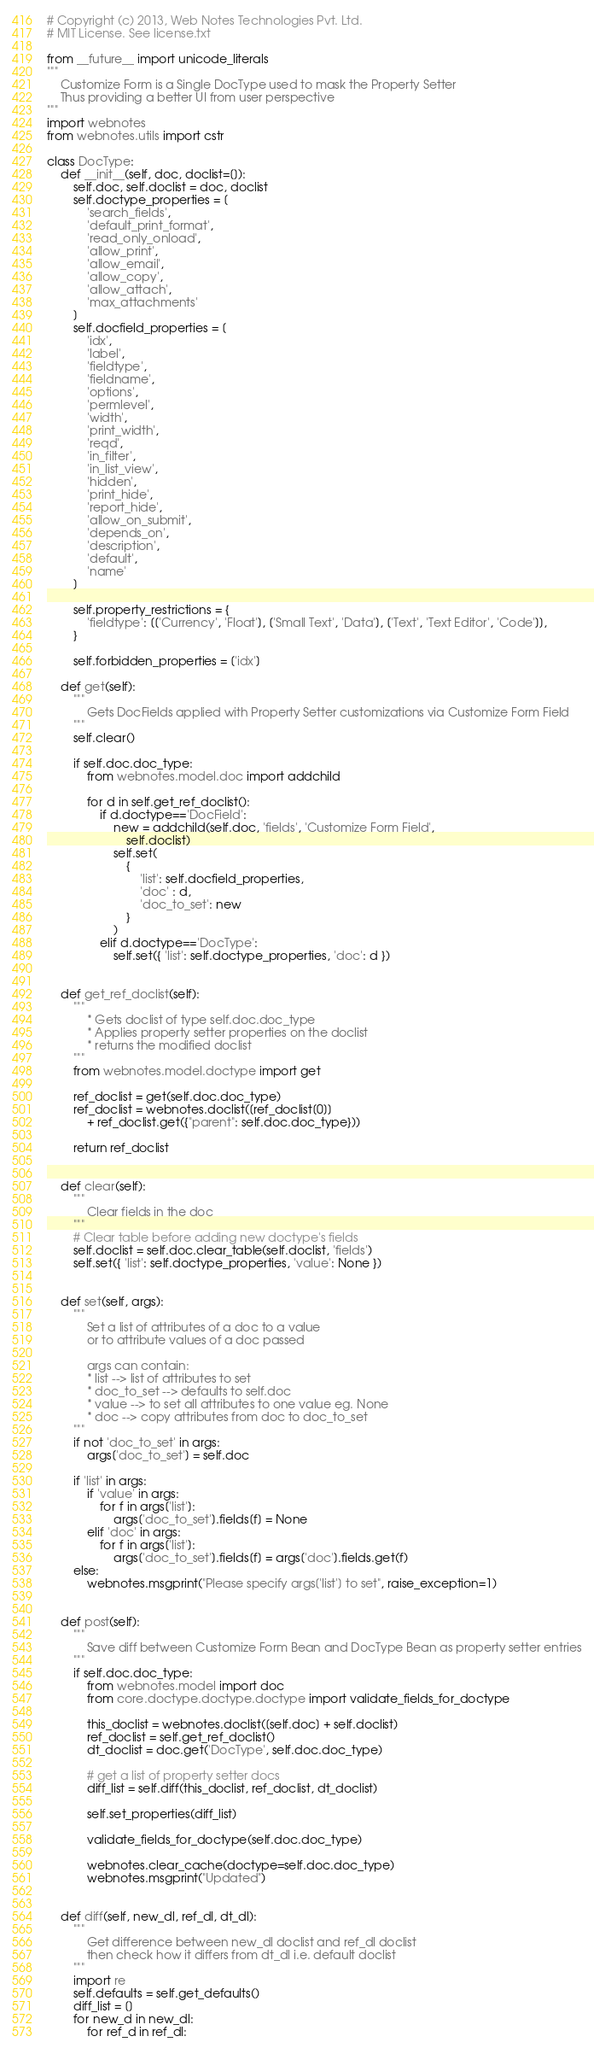<code> <loc_0><loc_0><loc_500><loc_500><_Python_># Copyright (c) 2013, Web Notes Technologies Pvt. Ltd.
# MIT License. See license.txt 

from __future__ import unicode_literals
"""
	Customize Form is a Single DocType used to mask the Property Setter
	Thus providing a better UI from user perspective
"""
import webnotes
from webnotes.utils import cstr

class DocType:
	def __init__(self, doc, doclist=[]):
		self.doc, self.doclist = doc, doclist
		self.doctype_properties = [
			'search_fields',
			'default_print_format',
			'read_only_onload',
			'allow_print',
			'allow_email',
			'allow_copy',
			'allow_attach',
			'max_attachments' 
		]
		self.docfield_properties = [
			'idx',
			'label',
			'fieldtype',
			'fieldname',
			'options',
			'permlevel',
			'width',
			'print_width',
			'reqd',
			'in_filter',
			'in_list_view',
			'hidden',
			'print_hide',
			'report_hide',
			'allow_on_submit',
			'depends_on',
			'description',
			'default',
			'name'
		]

		self.property_restrictions = {
			'fieldtype': [['Currency', 'Float'], ['Small Text', 'Data'], ['Text', 'Text Editor', 'Code']],
		}

		self.forbidden_properties = ['idx']

	def get(self):
		"""
			Gets DocFields applied with Property Setter customizations via Customize Form Field
		"""
		self.clear()

		if self.doc.doc_type:
			from webnotes.model.doc import addchild

			for d in self.get_ref_doclist():
				if d.doctype=='DocField':
					new = addchild(self.doc, 'fields', 'Customize Form Field', 
						self.doclist)
					self.set(
						{
							'list': self.docfield_properties,
							'doc' : d,
							'doc_to_set': new
						}
					)
				elif d.doctype=='DocType':
					self.set({ 'list': self.doctype_properties, 'doc': d })


	def get_ref_doclist(self):
		"""
			* Gets doclist of type self.doc.doc_type
			* Applies property setter properties on the doclist
			* returns the modified doclist
		"""
		from webnotes.model.doctype import get
		
		ref_doclist = get(self.doc.doc_type)
		ref_doclist = webnotes.doclist([ref_doclist[0]] 
			+ ref_doclist.get({"parent": self.doc.doc_type}))

		return ref_doclist


	def clear(self):
		"""
			Clear fields in the doc
		"""
		# Clear table before adding new doctype's fields
		self.doclist = self.doc.clear_table(self.doclist, 'fields')
		self.set({ 'list': self.doctype_properties, 'value': None })
	
		
	def set(self, args):
		"""
			Set a list of attributes of a doc to a value
			or to attribute values of a doc passed
			
			args can contain:
			* list --> list of attributes to set
			* doc_to_set --> defaults to self.doc
			* value --> to set all attributes to one value eg. None
			* doc --> copy attributes from doc to doc_to_set
		"""
		if not 'doc_to_set' in args:
			args['doc_to_set'] = self.doc

		if 'list' in args:
			if 'value' in args:
				for f in args['list']:
					args['doc_to_set'].fields[f] = None
			elif 'doc' in args:
				for f in args['list']:
					args['doc_to_set'].fields[f] = args['doc'].fields.get(f)
		else:
			webnotes.msgprint("Please specify args['list'] to set", raise_exception=1)


	def post(self):
		"""
			Save diff between Customize Form Bean and DocType Bean as property setter entries
		"""
		if self.doc.doc_type:
			from webnotes.model import doc
			from core.doctype.doctype.doctype import validate_fields_for_doctype
			
			this_doclist = webnotes.doclist([self.doc] + self.doclist)
			ref_doclist = self.get_ref_doclist()
			dt_doclist = doc.get('DocType', self.doc.doc_type)
			
			# get a list of property setter docs
			diff_list = self.diff(this_doclist, ref_doclist, dt_doclist)
			
			self.set_properties(diff_list)

			validate_fields_for_doctype(self.doc.doc_type)

			webnotes.clear_cache(doctype=self.doc.doc_type)
			webnotes.msgprint("Updated")


	def diff(self, new_dl, ref_dl, dt_dl):
		"""
			Get difference between new_dl doclist and ref_dl doclist
			then check how it differs from dt_dl i.e. default doclist
		"""
		import re
		self.defaults = self.get_defaults()
		diff_list = []
		for new_d in new_dl:
			for ref_d in ref_dl:</code> 